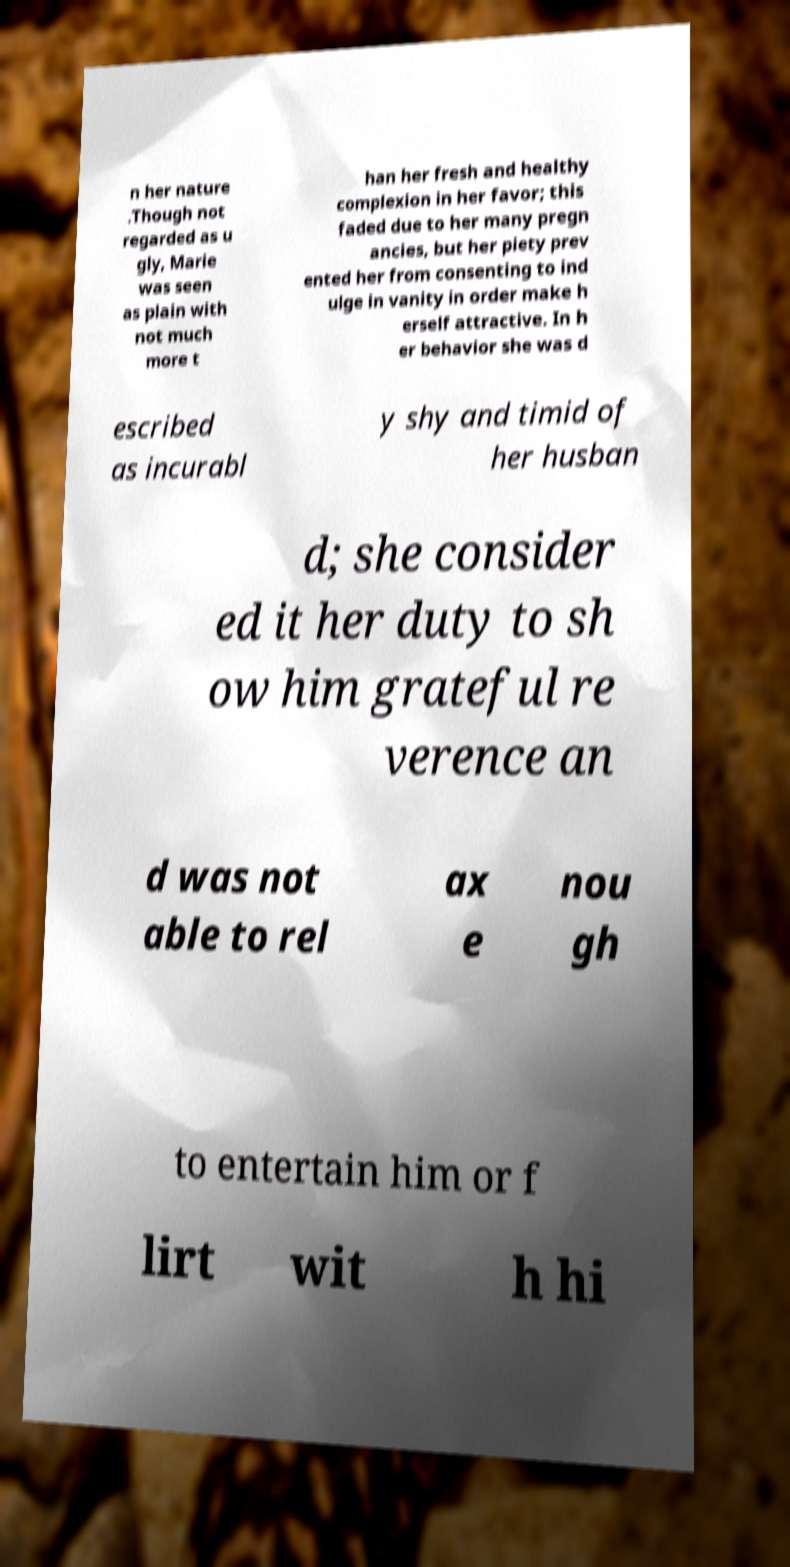For documentation purposes, I need the text within this image transcribed. Could you provide that? n her nature .Though not regarded as u gly, Marie was seen as plain with not much more t han her fresh and healthy complexion in her favor; this faded due to her many pregn ancies, but her piety prev ented her from consenting to ind ulge in vanity in order make h erself attractive. In h er behavior she was d escribed as incurabl y shy and timid of her husban d; she consider ed it her duty to sh ow him grateful re verence an d was not able to rel ax e nou gh to entertain him or f lirt wit h hi 